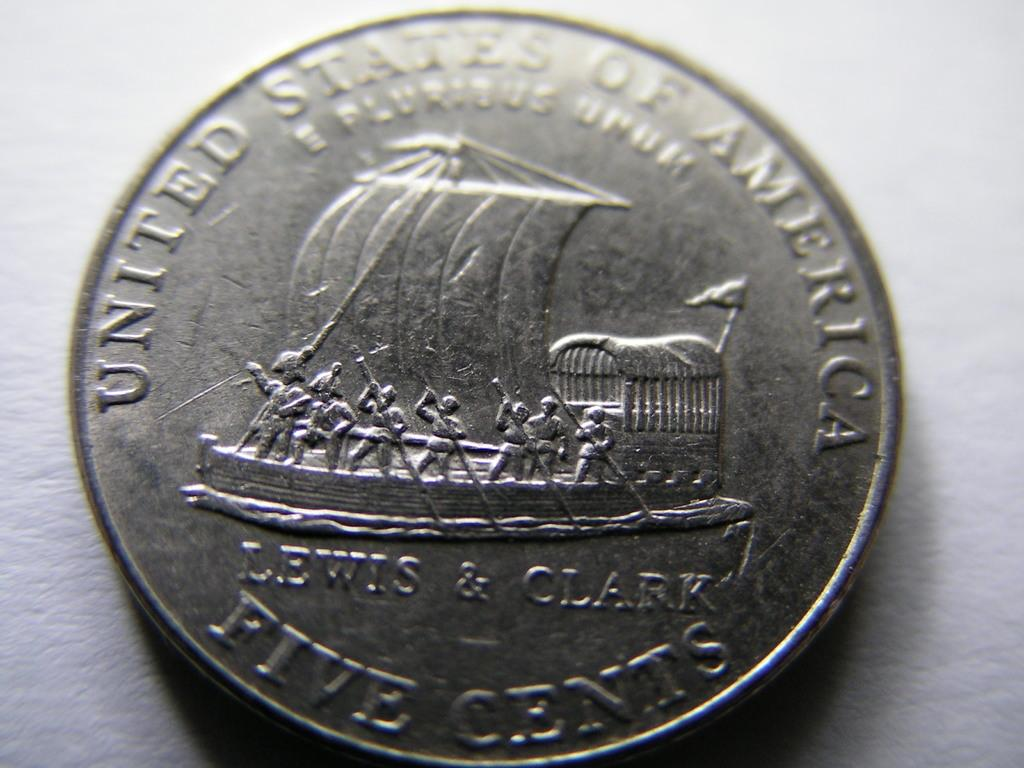Provide a one-sentence caption for the provided image. The coin shown is worth five cents in America. 